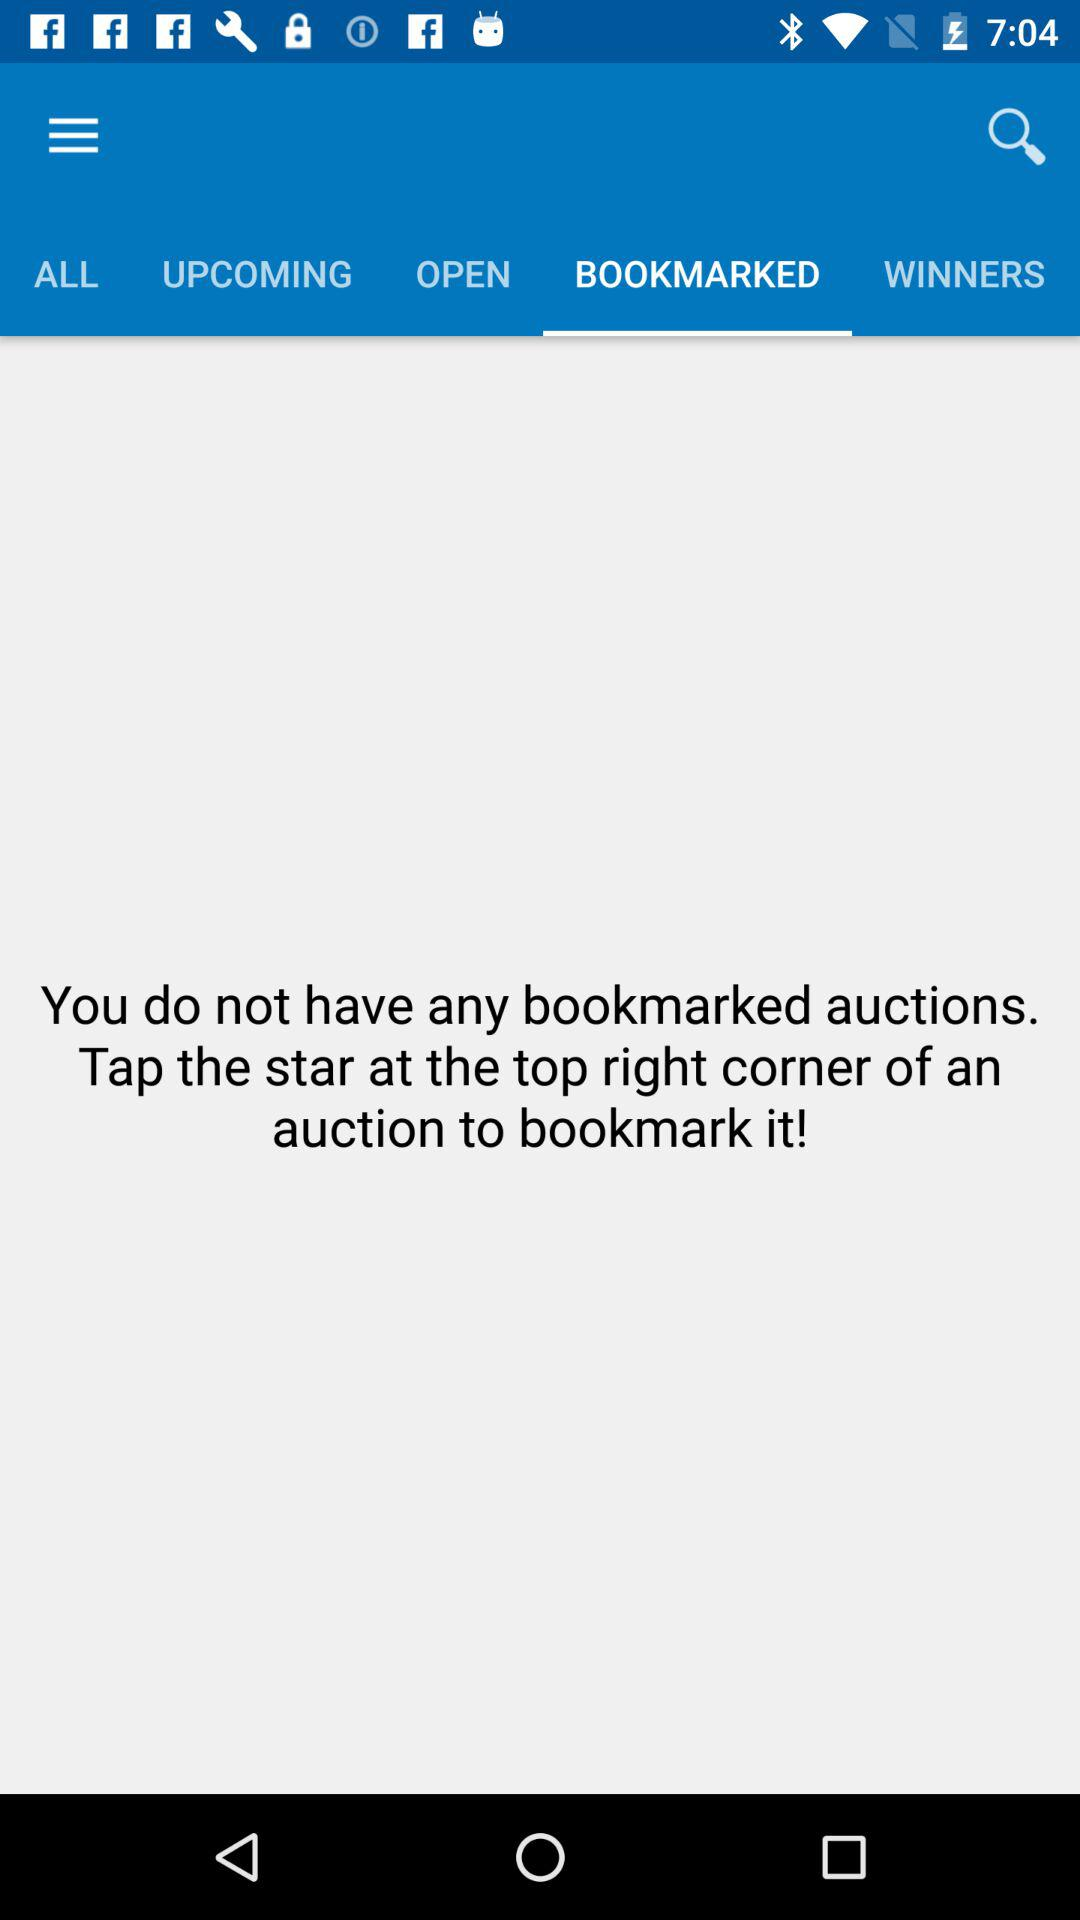How many auctions are in the bookmarked tab?
Answer the question using a single word or phrase. 0 